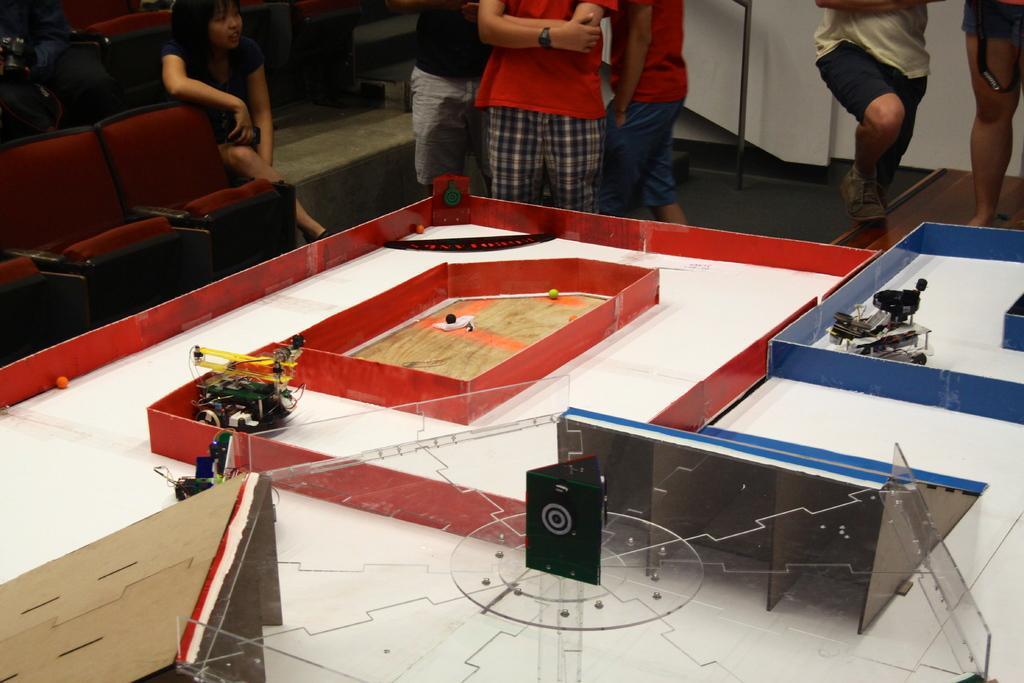Could you give a brief overview of what you see in this image? In the picture there is a table, on the table there are many items present, there are cars, there are many people standing near the table. 